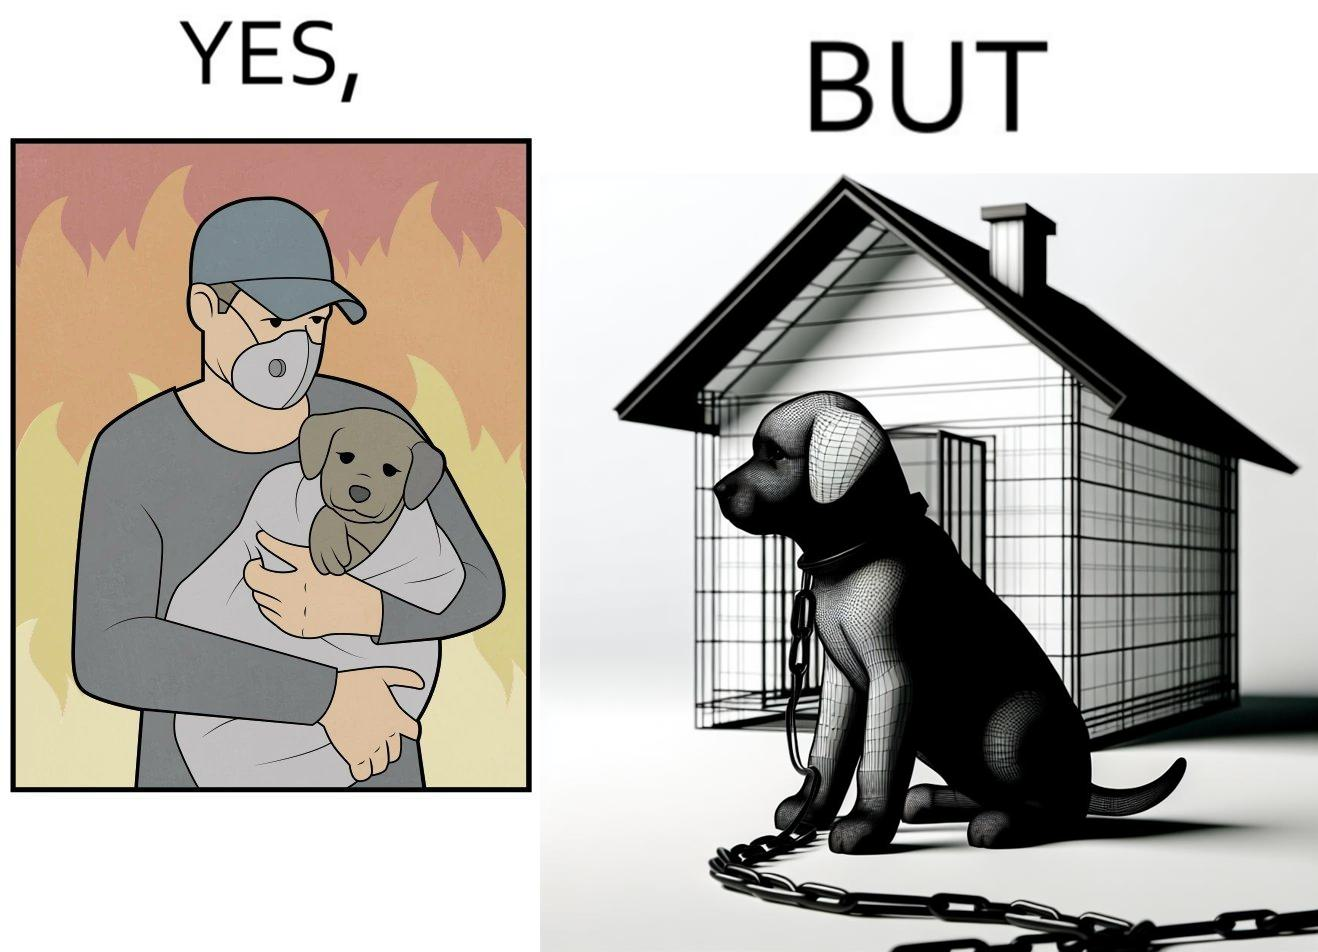What is the satirical meaning behind this image? The image is ironic, because in the left image the man is showing love and care for the puppy but in the right image the same puppy is shown to be chained in a kennel, which shows dual nature of human towards animals 